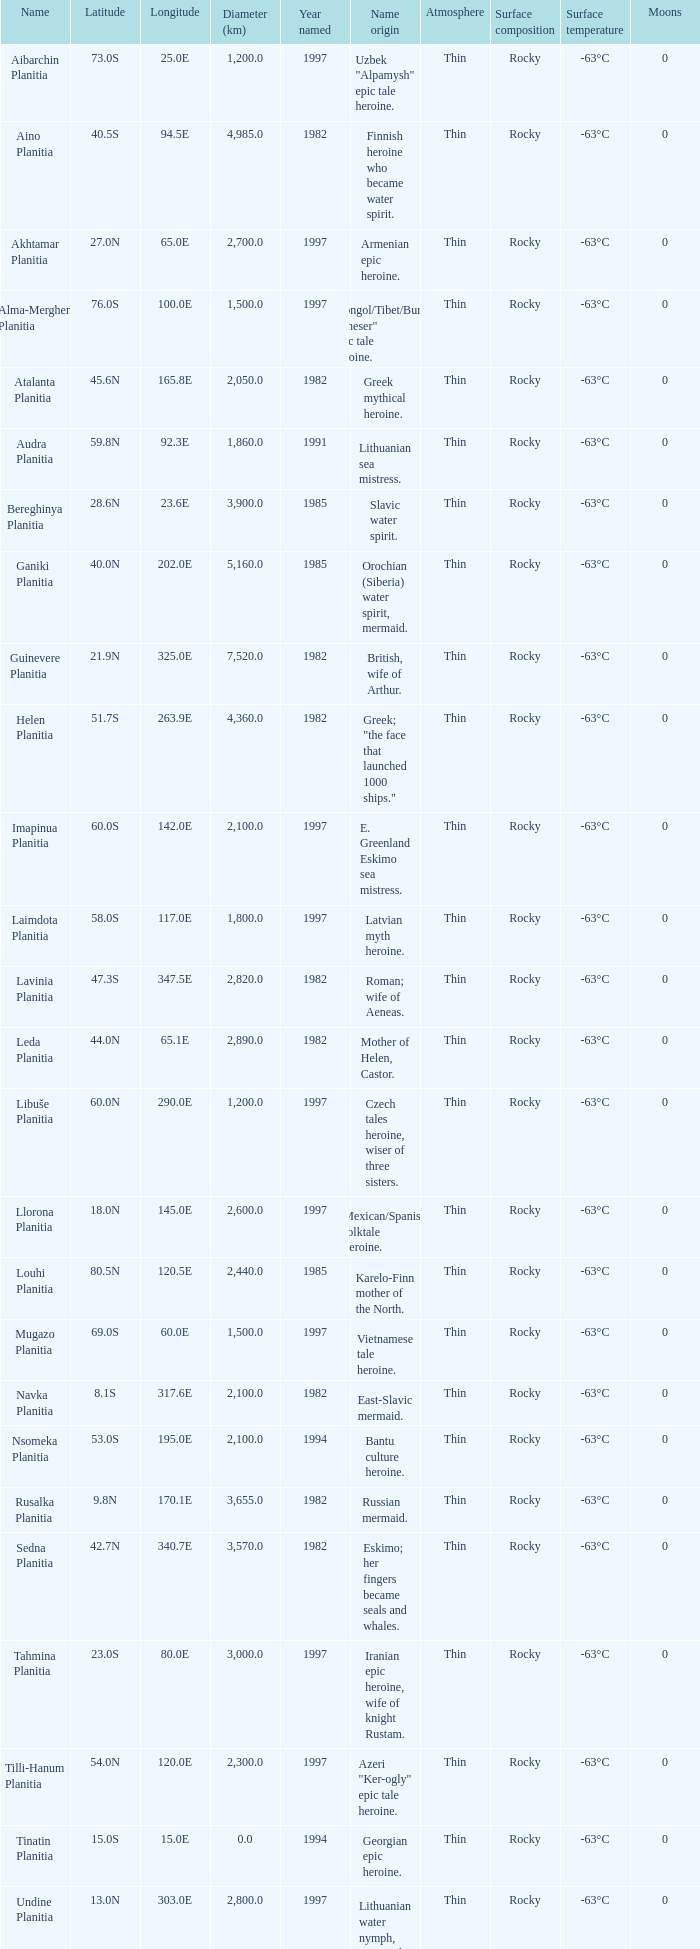What is the diameter (km) of the feature of latitude 23.0s 3000.0. 